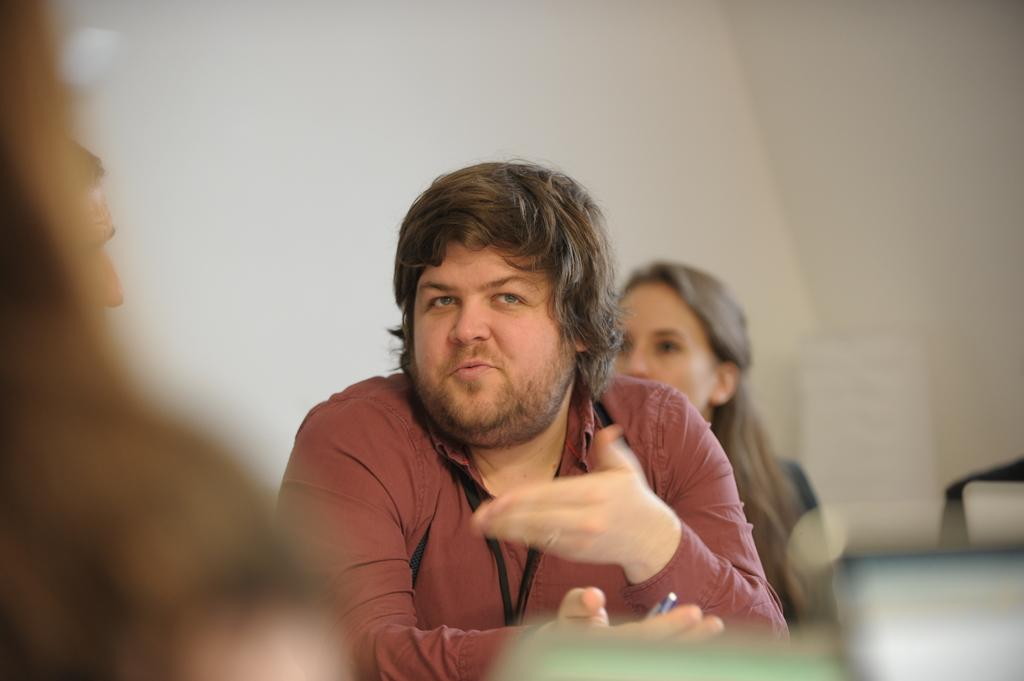How many persons are present in the image? There are two persons sitting in the image. Can you describe the background of the image? There is a wall in the background of the image. What type of fish can be seen swimming in the image? There are no fish present in the image. How many cattle are visible in the image? There are no cattle present in the image. 